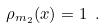Convert formula to latex. <formula><loc_0><loc_0><loc_500><loc_500>\rho _ { m _ { 2 } } ( x ) = 1 \ .</formula> 